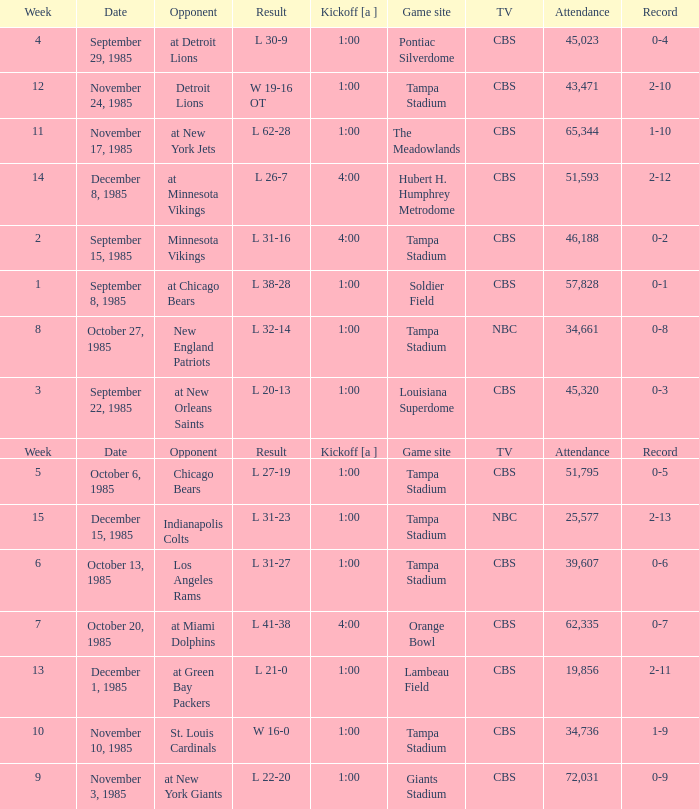Give me the kickoff time of the game that was aired on CBS against the St. Louis Cardinals.  1:00. 